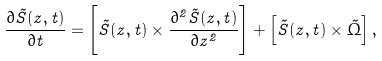Convert formula to latex. <formula><loc_0><loc_0><loc_500><loc_500>\frac { \partial \vec { S } ( z , t ) } { \partial t } = \left [ \vec { S } ( z , t ) \times \frac { \partial ^ { 2 } \vec { S } ( z , t ) } { \partial z ^ { 2 } } \right ] + \left [ \vec { S } ( z , t ) \times \vec { \Omega } \right ] ,</formula> 